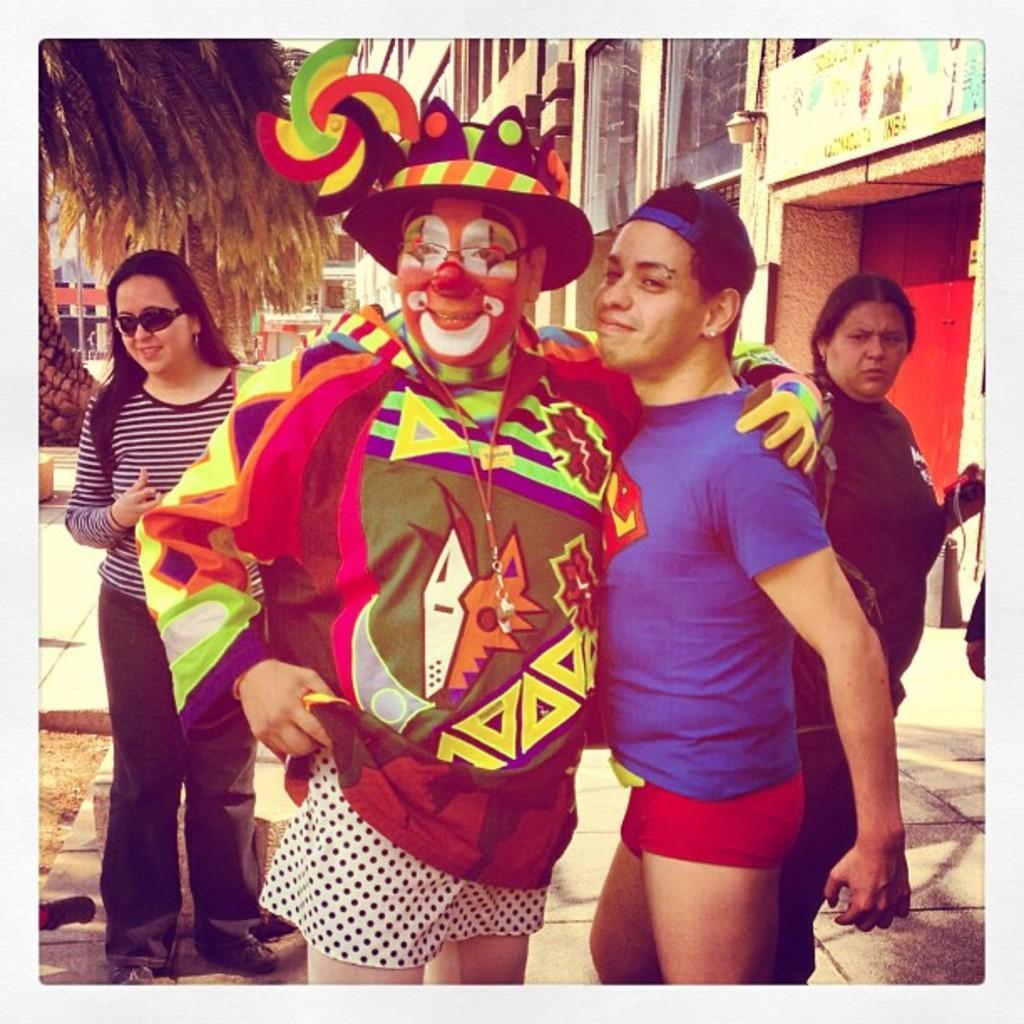Could you give a brief overview of what you see in this image? In this image there is a person wearing a costume of a joker, beside him there is a person standing, behind them there are two girls standing. In the background there are buildings and a tree. 